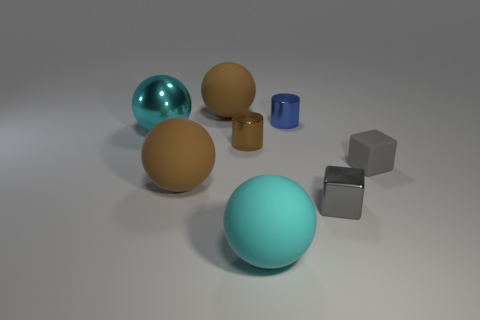The large rubber thing right of the large rubber object that is behind the large cyan shiny ball is what color?
Provide a succinct answer. Cyan. There is a blue object that is the same shape as the tiny brown metallic thing; what material is it?
Ensure brevity in your answer.  Metal. What color is the small metallic cylinder on the left side of the cyan rubber sphere in front of the large brown rubber thing that is in front of the small matte cube?
Offer a very short reply. Brown. How many objects are either gray metal cylinders or large brown spheres?
Provide a short and direct response. 2. How many large brown things are the same shape as the blue metallic object?
Offer a terse response. 0. Is the material of the small blue cylinder the same as the cyan thing that is in front of the small brown cylinder?
Offer a very short reply. No. There is a gray object that is made of the same material as the blue cylinder; what size is it?
Make the answer very short. Small. What size is the brown sphere that is behind the gray rubber thing?
Your answer should be compact. Large. What number of other brown cylinders are the same size as the brown metallic cylinder?
Provide a short and direct response. 0. There is another object that is the same color as the tiny rubber object; what size is it?
Ensure brevity in your answer.  Small. 